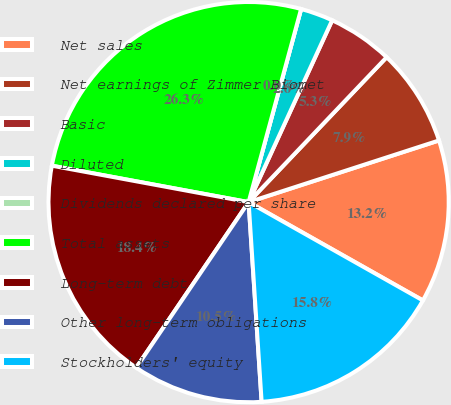Convert chart to OTSL. <chart><loc_0><loc_0><loc_500><loc_500><pie_chart><fcel>Net sales<fcel>Net earnings of Zimmer Biomet<fcel>Basic<fcel>Diluted<fcel>Dividends declared per share<fcel>Total assets<fcel>Long-term debt<fcel>Other long-term obligations<fcel>Stockholders' equity<nl><fcel>13.16%<fcel>7.9%<fcel>5.26%<fcel>2.63%<fcel>0.0%<fcel>26.31%<fcel>18.42%<fcel>10.53%<fcel>15.79%<nl></chart> 